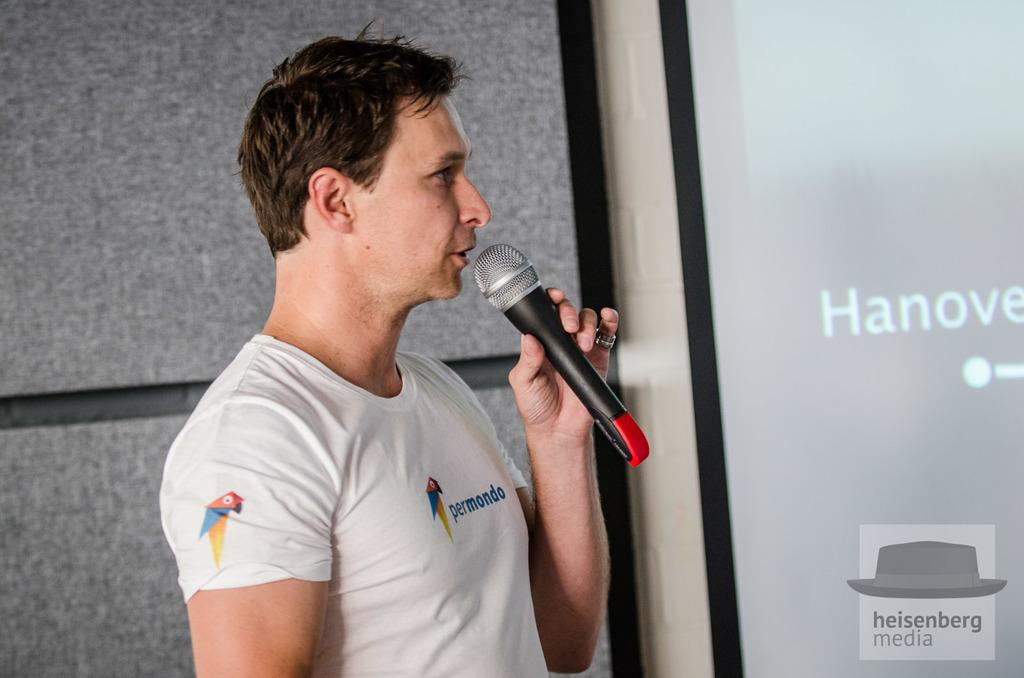What is the main subject of the image? There is a person in the image. What is the person doing in the image? The person is standing and speaking in the image. What object is the person holding? The person is holding a microphone. What can be seen in the background of the image? There is a wall in the image. What type of hen can be seen resting on the wall in the image? There is no hen present in the image, and the wall does not show any resting animals. 